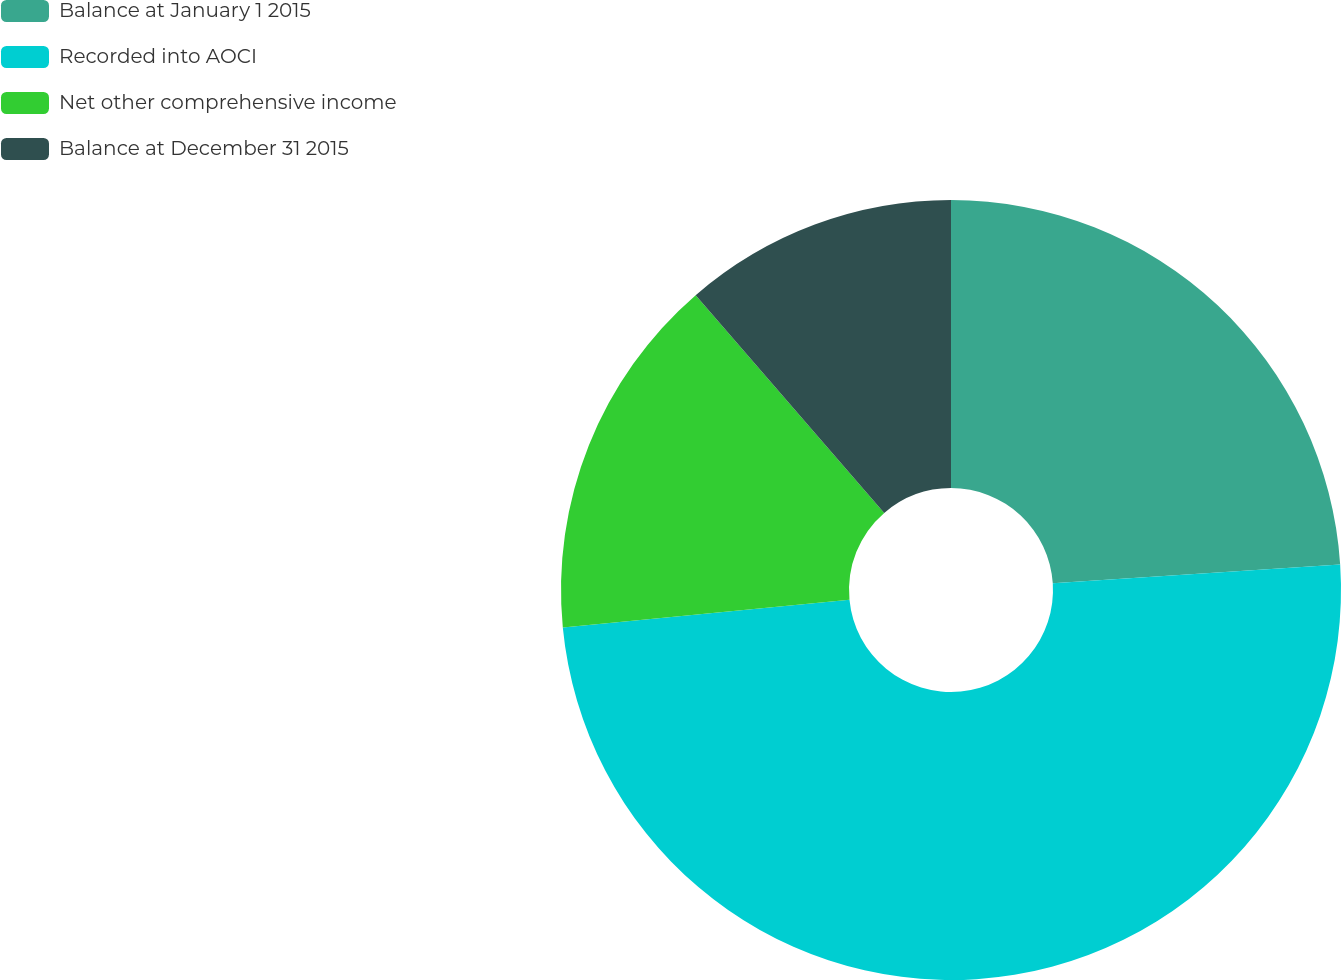Convert chart. <chart><loc_0><loc_0><loc_500><loc_500><pie_chart><fcel>Balance at January 1 2015<fcel>Recorded into AOCI<fcel>Net other comprehensive income<fcel>Balance at December 31 2015<nl><fcel>23.96%<fcel>49.51%<fcel>15.17%<fcel>11.36%<nl></chart> 